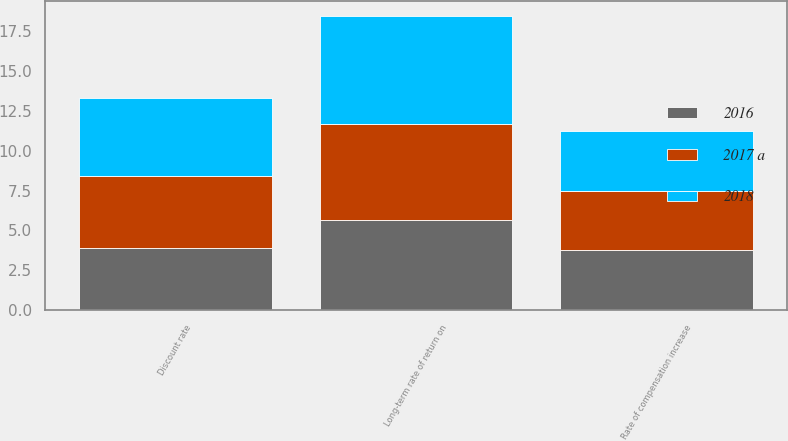Convert chart. <chart><loc_0><loc_0><loc_500><loc_500><stacked_bar_chart><ecel><fcel>Discount rate<fcel>Long-term rate of return on<fcel>Rate of compensation increase<nl><fcel>2016<fcel>3.9<fcel>5.65<fcel>3.75<nl><fcel>2017 a<fcel>4.53<fcel>6.06<fcel>3.75<nl><fcel>2018<fcel>4.9<fcel>6.75<fcel>3.75<nl></chart> 